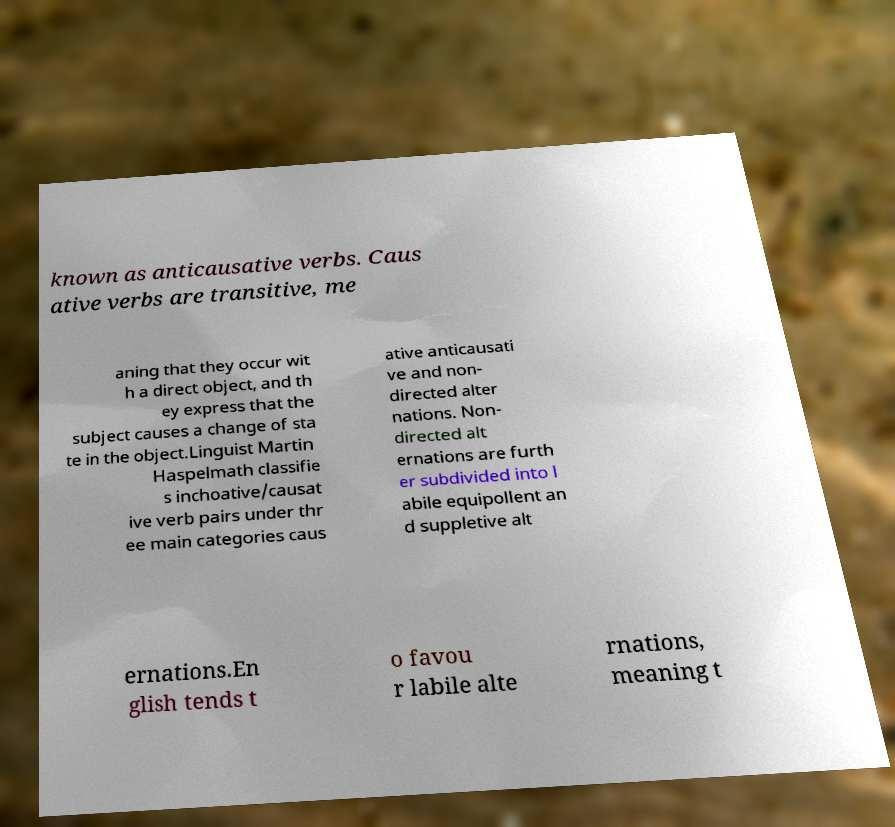Please read and relay the text visible in this image. What does it say? known as anticausative verbs. Caus ative verbs are transitive, me aning that they occur wit h a direct object, and th ey express that the subject causes a change of sta te in the object.Linguist Martin Haspelmath classifie s inchoative/causat ive verb pairs under thr ee main categories caus ative anticausati ve and non- directed alter nations. Non- directed alt ernations are furth er subdivided into l abile equipollent an d suppletive alt ernations.En glish tends t o favou r labile alte rnations, meaning t 